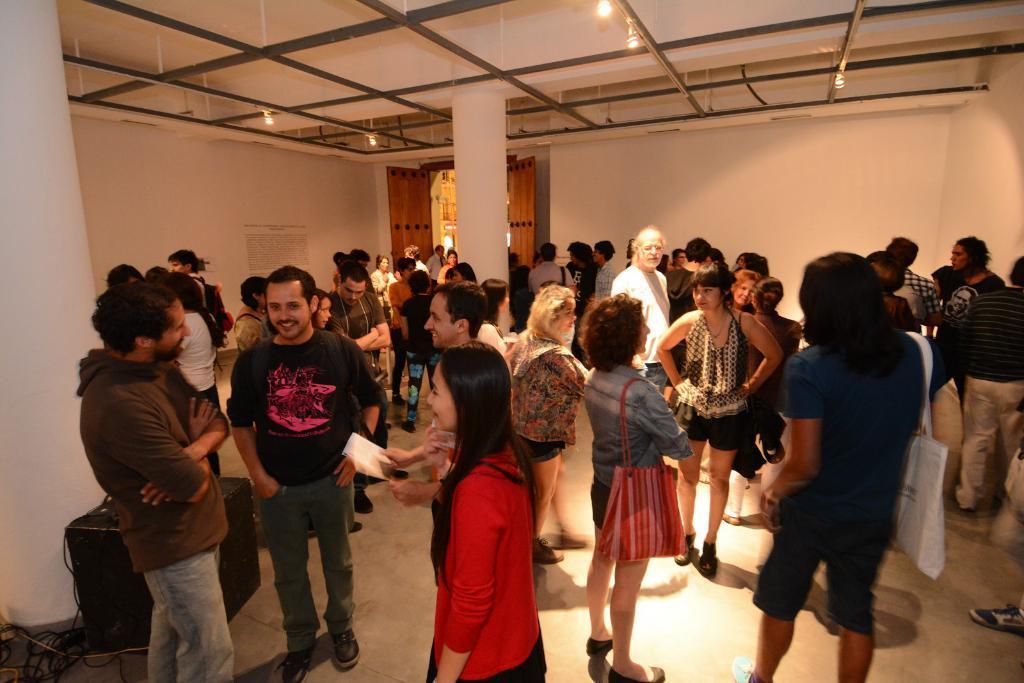In one or two sentences, can you explain what this image depicts? In this image we can see people standing on the floor, iron grills, electric lights, door, information board attached to the wall, cables and a speaker. 